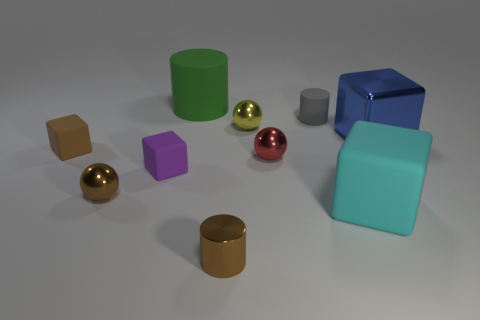The blue object that is the same size as the cyan thing is what shape? The blue object, which is identically sized in comparison to the cyan block to its right, is a cube. It's an example of a regular hexahedron, where all six faces are squares and all edges are of equal length. 